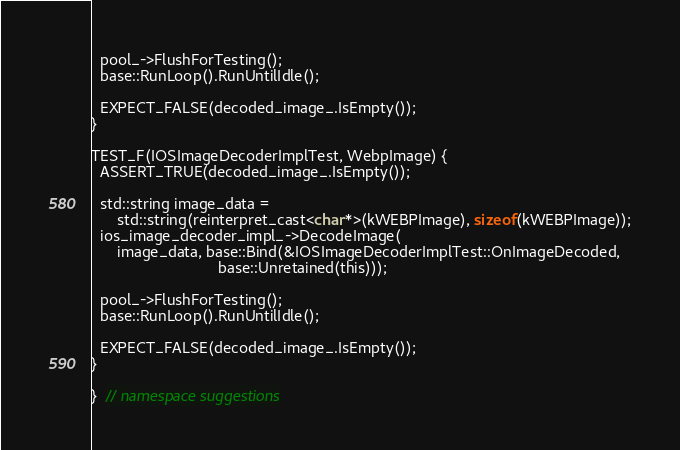<code> <loc_0><loc_0><loc_500><loc_500><_ObjectiveC_>
  pool_->FlushForTesting();
  base::RunLoop().RunUntilIdle();

  EXPECT_FALSE(decoded_image_.IsEmpty());
}

TEST_F(IOSImageDecoderImplTest, WebpImage) {
  ASSERT_TRUE(decoded_image_.IsEmpty());

  std::string image_data =
      std::string(reinterpret_cast<char*>(kWEBPImage), sizeof(kWEBPImage));
  ios_image_decoder_impl_->DecodeImage(
      image_data, base::Bind(&IOSImageDecoderImplTest::OnImageDecoded,
                             base::Unretained(this)));

  pool_->FlushForTesting();
  base::RunLoop().RunUntilIdle();

  EXPECT_FALSE(decoded_image_.IsEmpty());
}

}  // namespace suggestions
</code> 